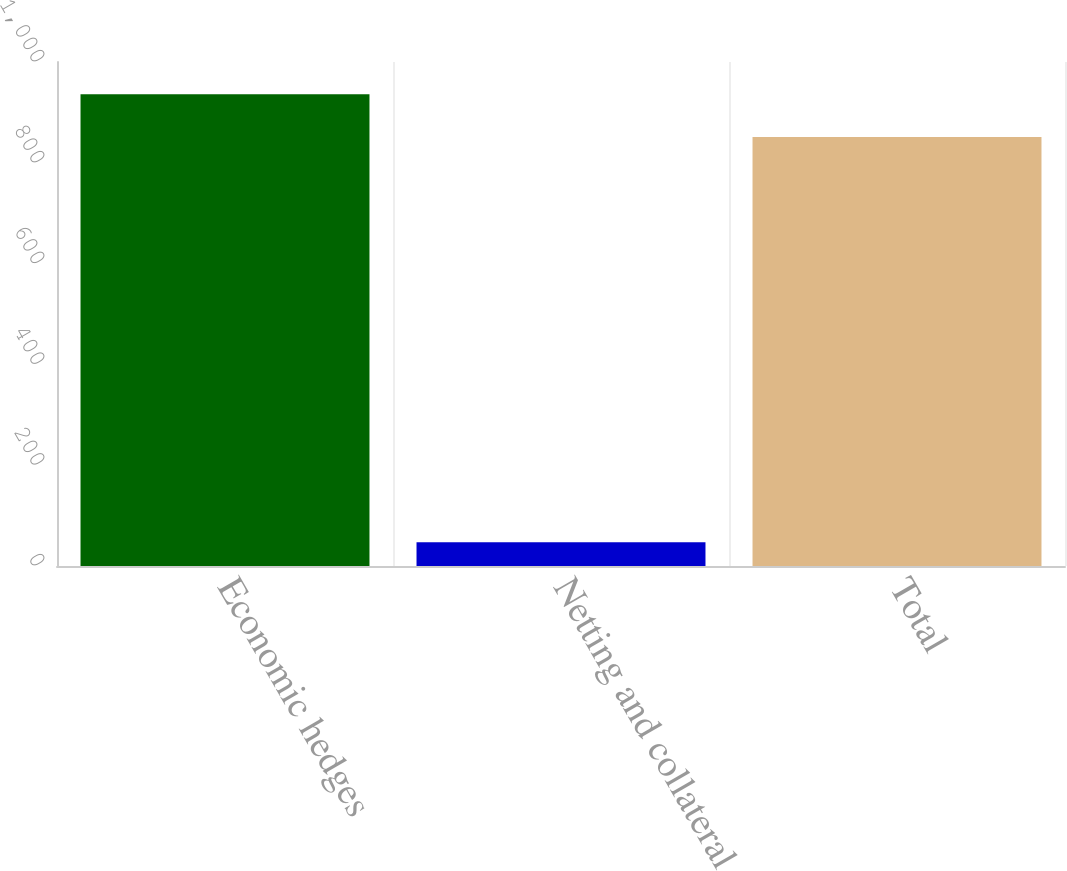Convert chart. <chart><loc_0><loc_0><loc_500><loc_500><bar_chart><fcel>Economic hedges<fcel>Netting and collateral<fcel>Total<nl><fcel>936.1<fcel>47<fcel>851<nl></chart> 